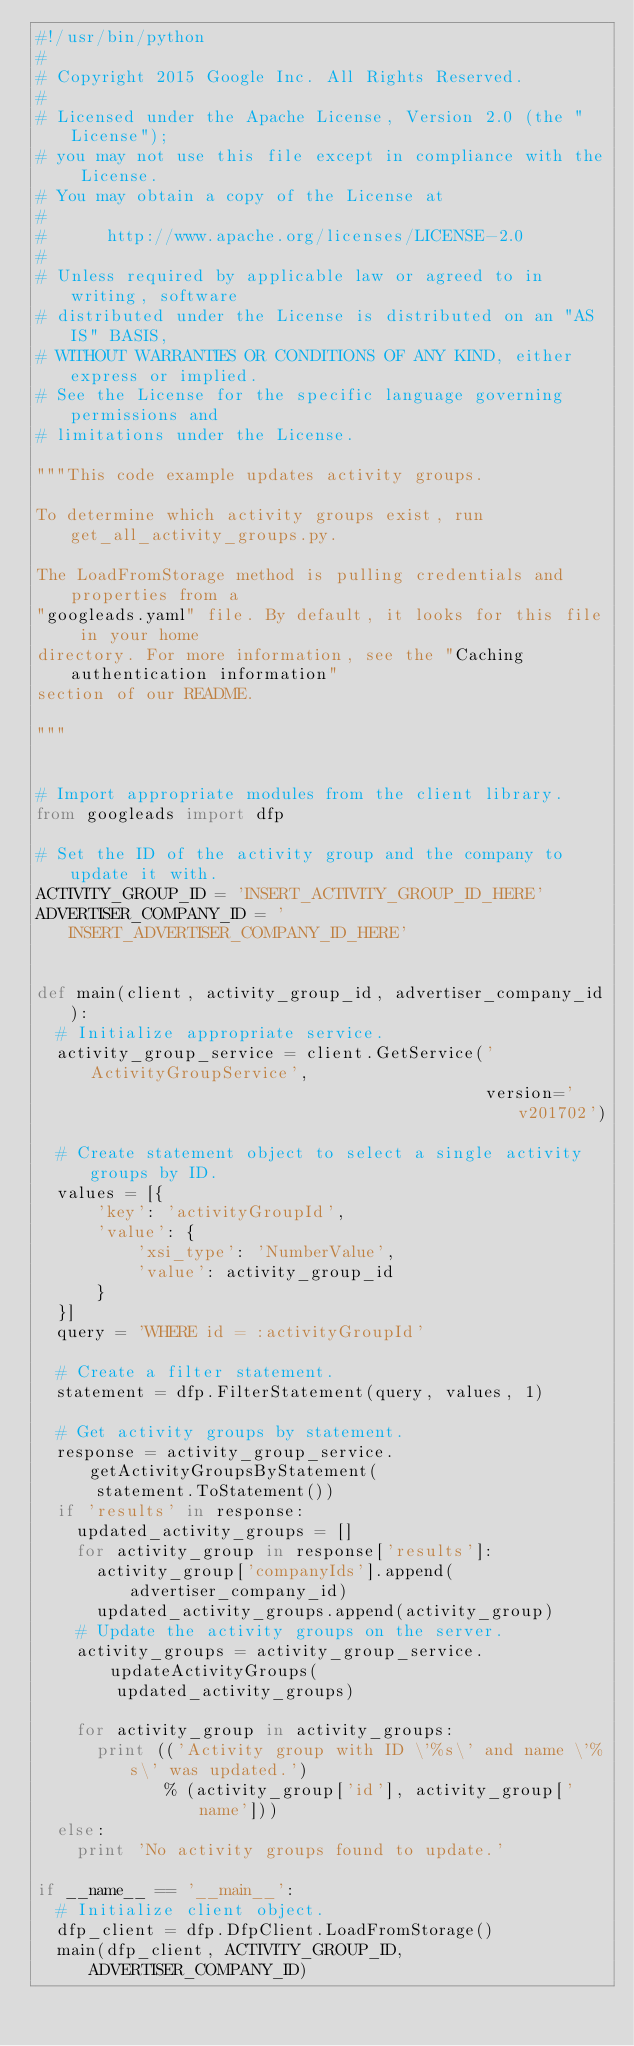Convert code to text. <code><loc_0><loc_0><loc_500><loc_500><_Python_>#!/usr/bin/python
#
# Copyright 2015 Google Inc. All Rights Reserved.
#
# Licensed under the Apache License, Version 2.0 (the "License");
# you may not use this file except in compliance with the License.
# You may obtain a copy of the License at
#
#      http://www.apache.org/licenses/LICENSE-2.0
#
# Unless required by applicable law or agreed to in writing, software
# distributed under the License is distributed on an "AS IS" BASIS,
# WITHOUT WARRANTIES OR CONDITIONS OF ANY KIND, either express or implied.
# See the License for the specific language governing permissions and
# limitations under the License.

"""This code example updates activity groups.

To determine which activity groups exist, run get_all_activity_groups.py.

The LoadFromStorage method is pulling credentials and properties from a
"googleads.yaml" file. By default, it looks for this file in your home
directory. For more information, see the "Caching authentication information"
section of our README.

"""


# Import appropriate modules from the client library.
from googleads import dfp

# Set the ID of the activity group and the company to update it with.
ACTIVITY_GROUP_ID = 'INSERT_ACTIVITY_GROUP_ID_HERE'
ADVERTISER_COMPANY_ID = 'INSERT_ADVERTISER_COMPANY_ID_HERE'


def main(client, activity_group_id, advertiser_company_id):
  # Initialize appropriate service.
  activity_group_service = client.GetService('ActivityGroupService',
                                             version='v201702')

  # Create statement object to select a single activity groups by ID.
  values = [{
      'key': 'activityGroupId',
      'value': {
          'xsi_type': 'NumberValue',
          'value': activity_group_id
      }
  }]
  query = 'WHERE id = :activityGroupId'

  # Create a filter statement.
  statement = dfp.FilterStatement(query, values, 1)

  # Get activity groups by statement.
  response = activity_group_service.getActivityGroupsByStatement(
      statement.ToStatement())
  if 'results' in response:
    updated_activity_groups = []
    for activity_group in response['results']:
      activity_group['companyIds'].append(advertiser_company_id)
      updated_activity_groups.append(activity_group)
    # Update the activity groups on the server.
    activity_groups = activity_group_service.updateActivityGroups(
        updated_activity_groups)

    for activity_group in activity_groups:
      print (('Activity group with ID \'%s\' and name \'%s\' was updated.')
             % (activity_group['id'], activity_group['name']))
  else:
    print 'No activity groups found to update.'

if __name__ == '__main__':
  # Initialize client object.
  dfp_client = dfp.DfpClient.LoadFromStorage()
  main(dfp_client, ACTIVITY_GROUP_ID, ADVERTISER_COMPANY_ID)
</code> 